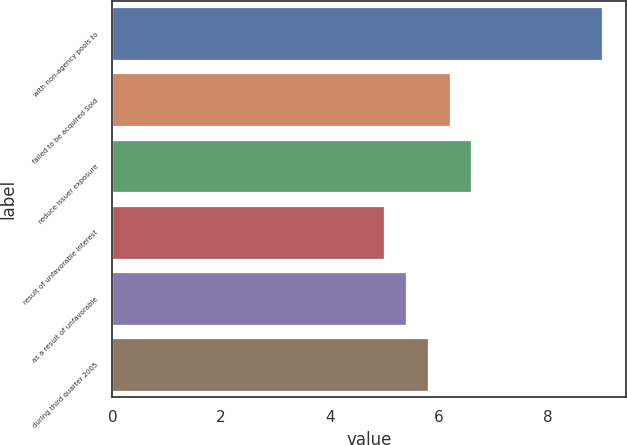<chart> <loc_0><loc_0><loc_500><loc_500><bar_chart><fcel>with non-agency pools to<fcel>failed to be acquired Sold<fcel>reduce issuer exposure<fcel>result of unfavorable interest<fcel>as a result of unfavorable<fcel>during third quarter 2005<nl><fcel>9<fcel>6.2<fcel>6.6<fcel>5<fcel>5.4<fcel>5.8<nl></chart> 